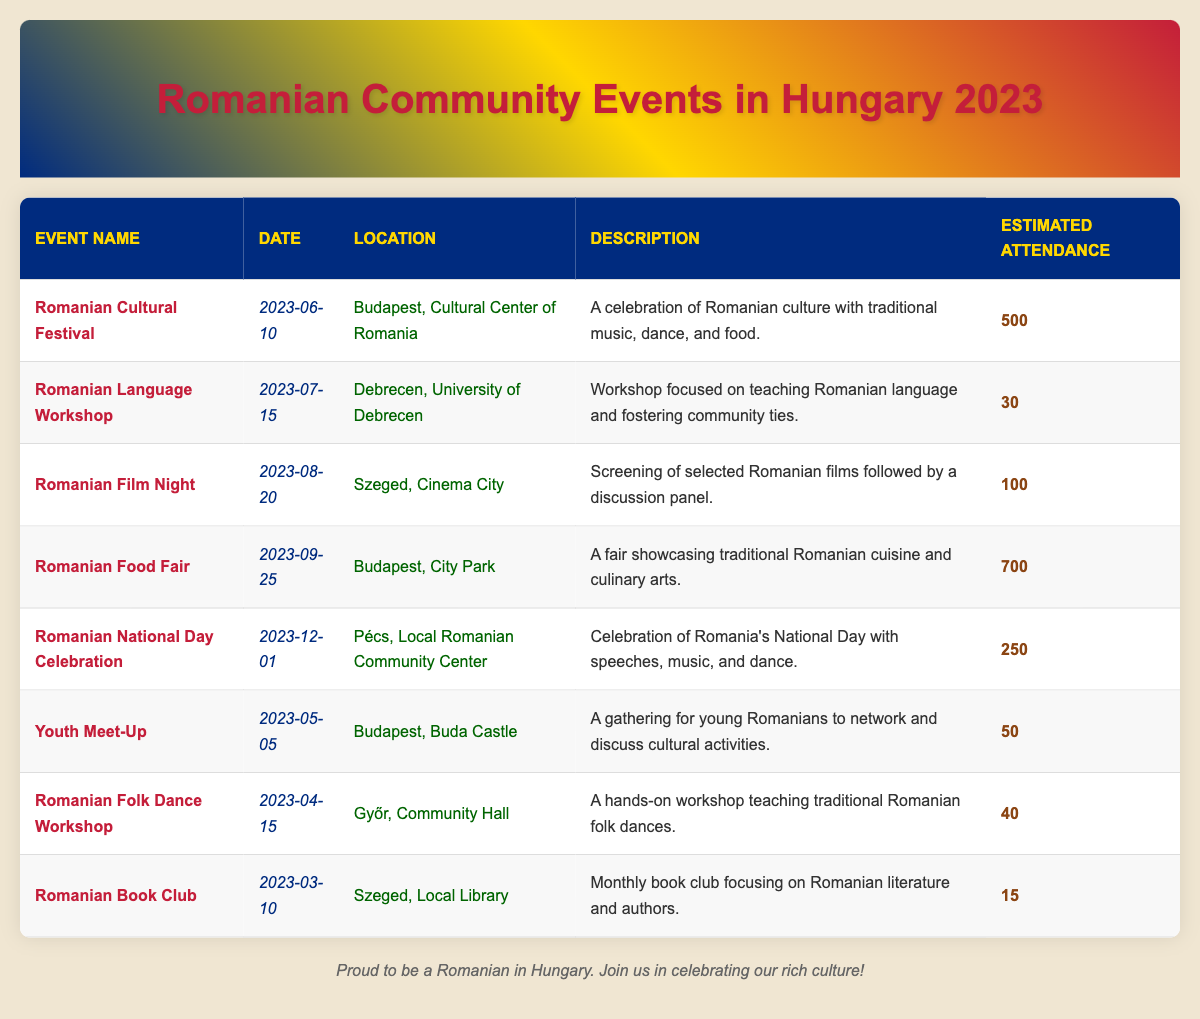What is the date of the Romanian Cultural Festival? The table lists the event name "Romanian Cultural Festival" with a corresponding date of "2023-06-10".
Answer: 2023-06-10 Where will the Romanian National Day Celebration take place? According to the table, the location for the "Romanian National Day Celebration" is "Pécs, Local Romanian Community Center".
Answer: Pécs, Local Romanian Community Center How many attendees are estimated for the Romanian Food Fair? The estimated attendance for the "Romanian Food Fair" as presented in the table is 700.
Answer: 700 What is the total estimated attendance for all events? The total estimated attendance can be calculated by adding each event's attendance: 500 + 30 + 100 + 700 + 250 + 50 + 40 + 15 = 1685.
Answer: 1685 Which event has the lowest expected attendance? By reviewing the table, "Romanian Book Club" has the lowest estimated attendance of 15.
Answer: 15 Was there an event focused on Romanian cuisine? Yes, the "Romanian Food Fair" is specifically focused on showcasing traditional Romanian cuisine.
Answer: Yes How many events are scheduled before June? The table lists three events before June: "Romanian Book Club", "Romanian Folk Dance Workshop", and "Youth Meet-Up".
Answer: 3 What is the average estimated attendance of the events? The average estimated attendance is calculated as total attendance (1685) divided by the number of events (8), which equals 1685/8 = 210.625, rounded to 211.
Answer: 211 Which event takes place at the University of Debrecen? The event listed for the University of Debrecen is the "Romanian Language Workshop", scheduled for July 15, 2023.
Answer: Romanian Language Workshop Is there an event focusing on Romanian literature? Yes, the "Romanian Book Club" focuses on Romanian literature and authors.
Answer: Yes 